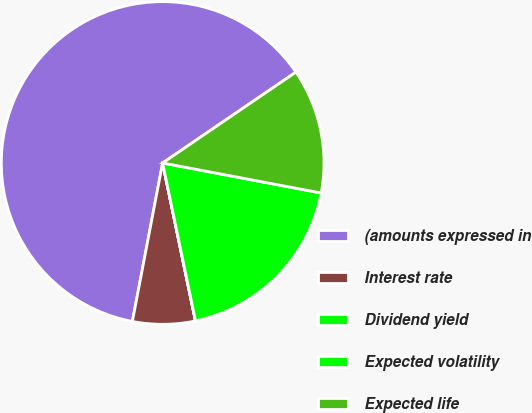Convert chart. <chart><loc_0><loc_0><loc_500><loc_500><pie_chart><fcel>(amounts expressed in<fcel>Interest rate<fcel>Dividend yield<fcel>Expected volatility<fcel>Expected life<nl><fcel>62.47%<fcel>6.26%<fcel>0.01%<fcel>18.75%<fcel>12.5%<nl></chart> 